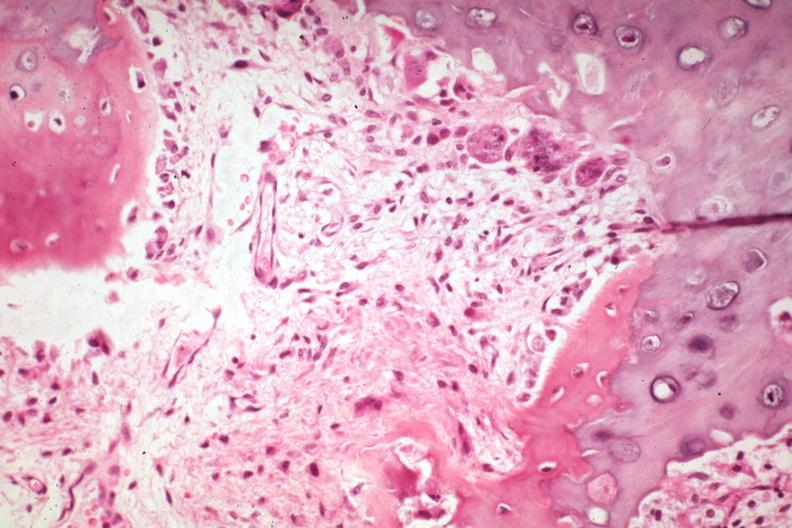what does this image show?
Answer the question using a single word or phrase. High excellent granulation tissue new bone formation and osteoclasts or chondroclasts 